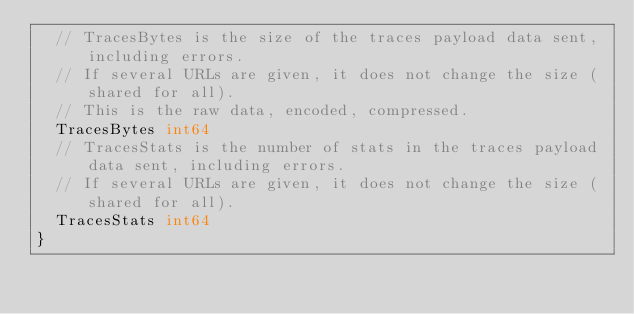<code> <loc_0><loc_0><loc_500><loc_500><_Go_>	// TracesBytes is the size of the traces payload data sent, including errors.
	// If several URLs are given, it does not change the size (shared for all).
	// This is the raw data, encoded, compressed.
	TracesBytes int64
	// TracesStats is the number of stats in the traces payload data sent, including errors.
	// If several URLs are given, it does not change the size (shared for all).
	TracesStats int64
}
</code> 